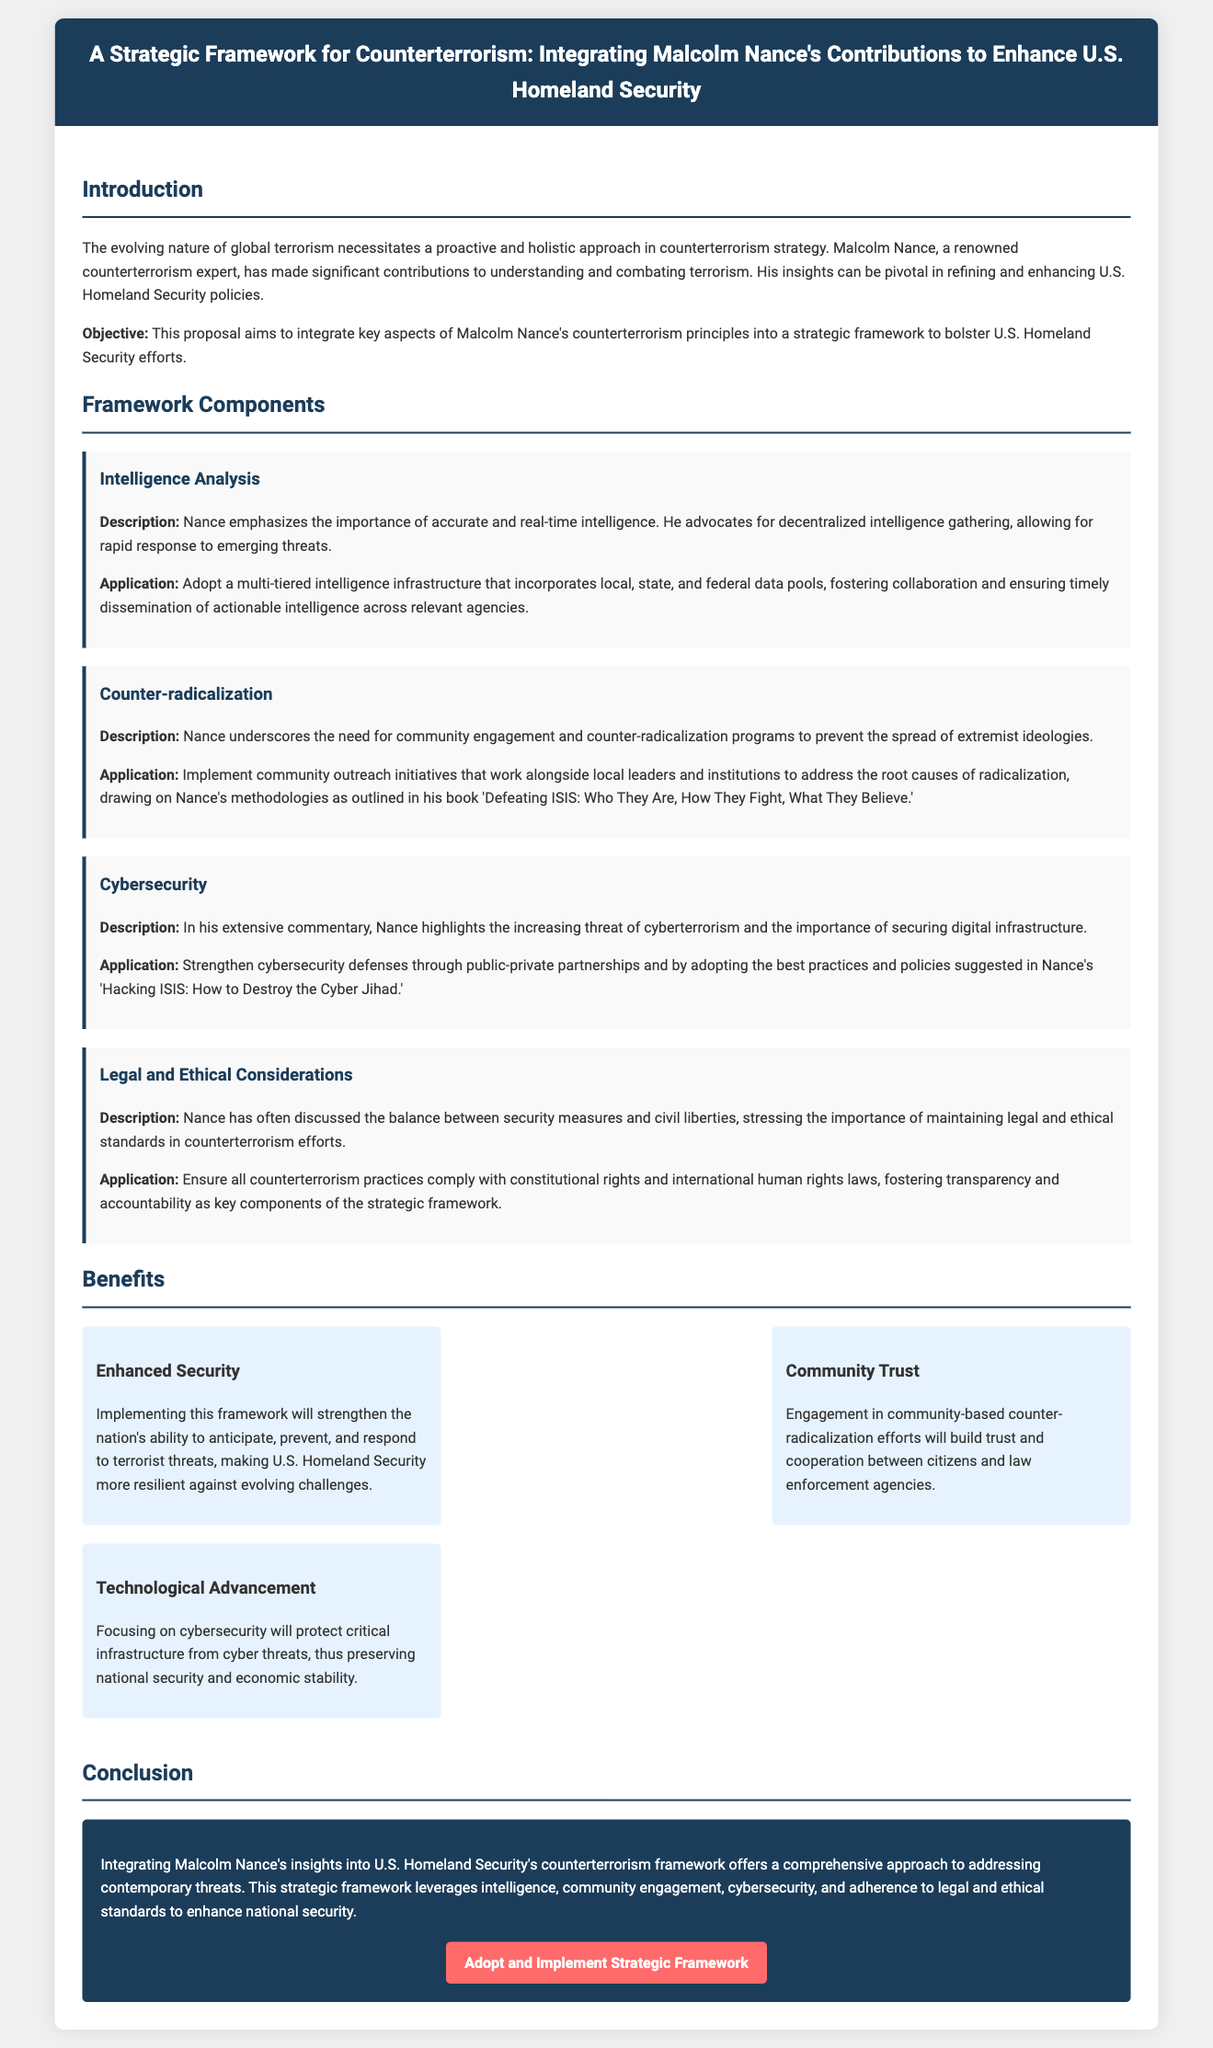What is the title of the proposal? The title of the proposal is stated at the top of the document, highlighting its focus on counterterrorism and Malcolm Nance's contributions.
Answer: A Strategic Framework for Counterterrorism: Integrating Malcolm Nance's Contributions to Enhance U.S. Homeland Security Who is the key figure discussed in the proposal? The proposal centers around Malcolm Nance, emphasizing his expertise and contributions to counterterrorism.
Answer: Malcolm Nance What is the objective of the proposal? The document specifies the proposal's objective to integrate Malcolm Nance's principles into U.S. Homeland Security efforts.
Answer: Integrate key aspects of Malcolm Nance's counterterrorism principles into a strategic framework What is one of the framework components? The document lists several framework components, highlighting specific areas of focus in the counterterrorism strategy.
Answer: Intelligence Analysis What is one benefit mentioned in the proposal? The proposal outlines various advantages of implementing the framework, focusing on security and community trust.
Answer: Enhanced Security How does the proposal suggest improving community trust? The proposal emphasizes community engagement initiatives as a way to build trust between citizens and law enforcement agencies.
Answer: Community-based counter-radicalization efforts What does the proposal highlight regarding legal and ethical considerations? The proposal discusses the importance of maintaining legal and ethical standards in counterterrorism measures.
Answer: Compliance with constitutional rights and international human rights laws What key issue does Malcolm Nance address in his commentary? The proposal reflects on Nance's commentary regarding the threats posed by cyberterrorism and the need for cybersecurity.
Answer: Cyberterrorism What call to action is presented in the conclusion? The conclusion of the proposal includes a specific call to action for adopting and implementing the strategic framework.
Answer: Adopt and Implement Strategic Framework 